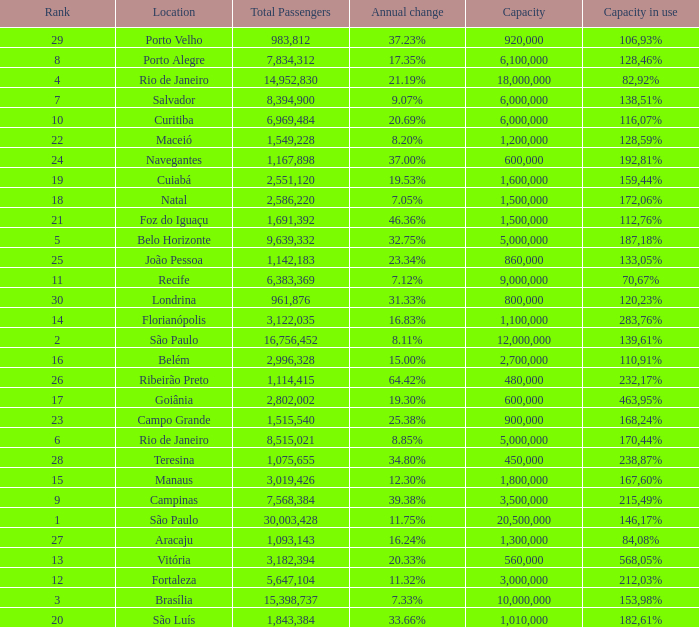What location has an in use capacity of 167,60%? 1800000.0. 